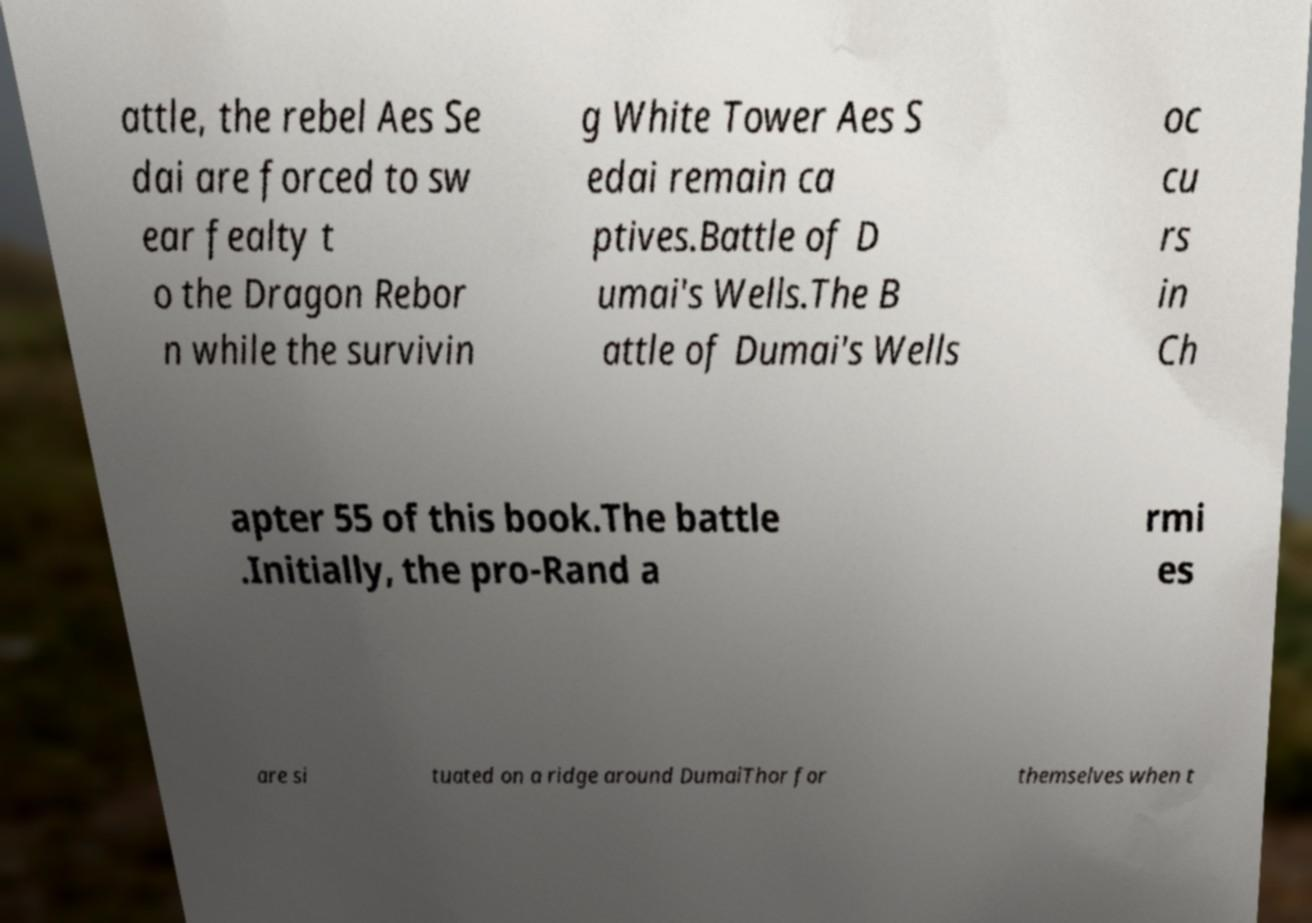Could you extract and type out the text from this image? attle, the rebel Aes Se dai are forced to sw ear fealty t o the Dragon Rebor n while the survivin g White Tower Aes S edai remain ca ptives.Battle of D umai's Wells.The B attle of Dumai's Wells oc cu rs in Ch apter 55 of this book.The battle .Initially, the pro-Rand a rmi es are si tuated on a ridge around DumaiThor for themselves when t 